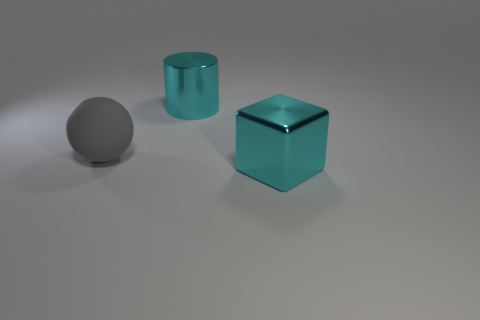Is the number of shiny things in front of the large shiny cylinder greater than the number of large brown metallic cylinders?
Ensure brevity in your answer.  Yes. Are there any large blocks that have the same material as the large sphere?
Your response must be concise. No. There is a object to the left of the big shiny thing behind the large gray rubber object; how many gray things are behind it?
Give a very brief answer. 0. Is the number of metallic objects on the left side of the big gray rubber thing less than the number of gray matte spheres that are right of the large cyan cylinder?
Provide a succinct answer. No. How many metallic blocks are the same size as the metal cylinder?
Provide a short and direct response. 1. Is the metal cylinder the same color as the block?
Provide a short and direct response. Yes. Does the cyan object behind the big cube have the same material as the thing that is in front of the large rubber thing?
Provide a succinct answer. Yes. Is the number of large balls greater than the number of big green metal cylinders?
Your response must be concise. Yes. Is there any other thing of the same color as the large block?
Your response must be concise. Yes. Is the cylinder made of the same material as the large gray sphere?
Your response must be concise. No. 